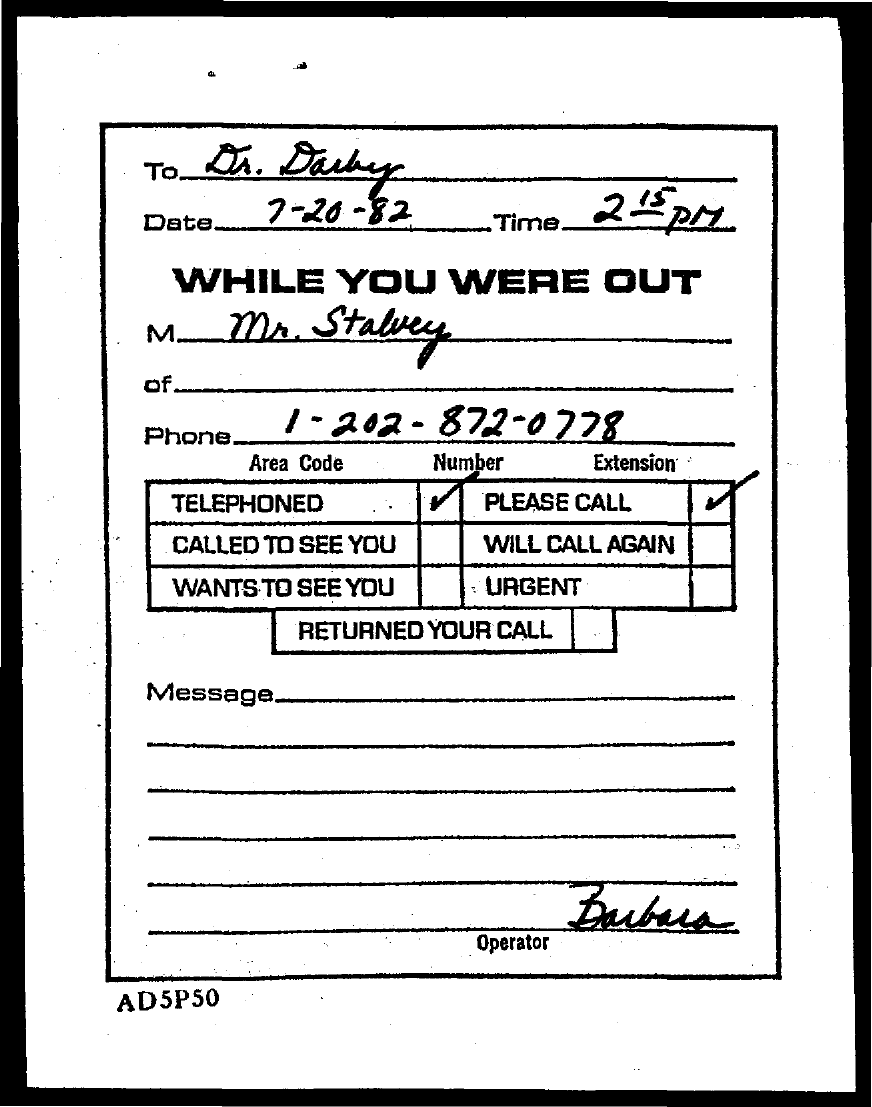To Whom is this message addressed to?
Your answer should be compact. Dr. Darby. What is the Date?
Offer a terse response. 7-20-82. What is the Phone?
Offer a very short reply. 1-202-872-0778. Who is the operator?
Ensure brevity in your answer.  Barbara. Who is the message from?
Keep it short and to the point. Mr. Stalvey. 